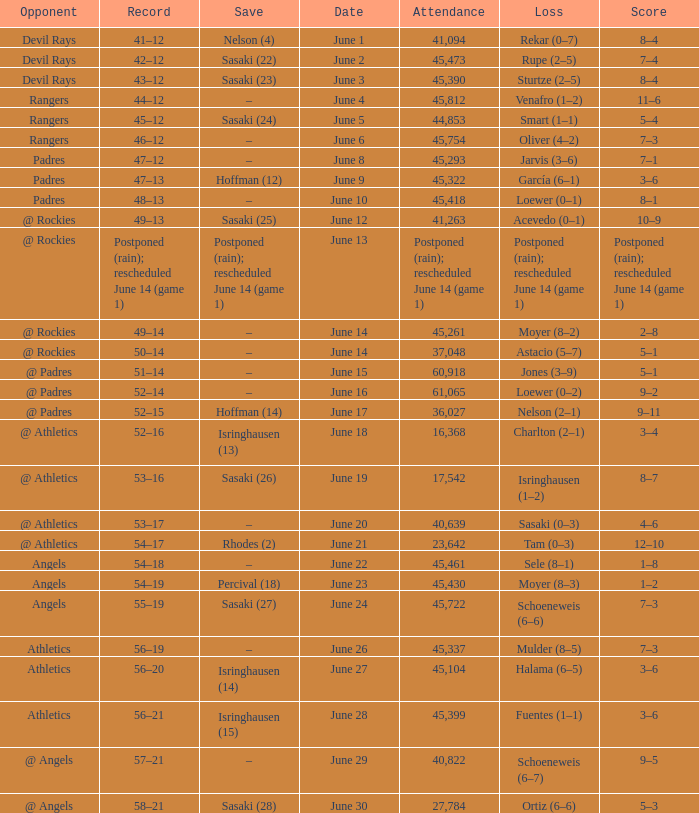What was the attendance of the Mariners game when they had a record of 56–20? 45104.0. 